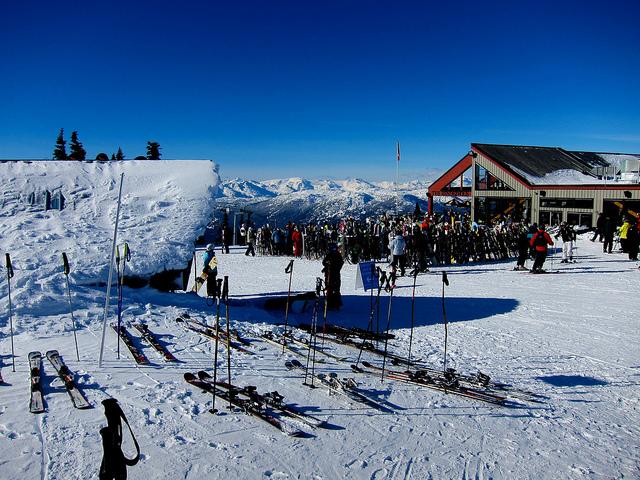Is someone wearing ski's?
Give a very brief answer. Yes. Is the day windy?
Write a very short answer. No. Has the snow seen a lot of traffic already?
Give a very brief answer. Yes. What type of marks are in the snow?
Quick response, please. Ski. Is this an old or new photo?
Write a very short answer. New. What is white on the ground?
Quick response, please. Snow. 